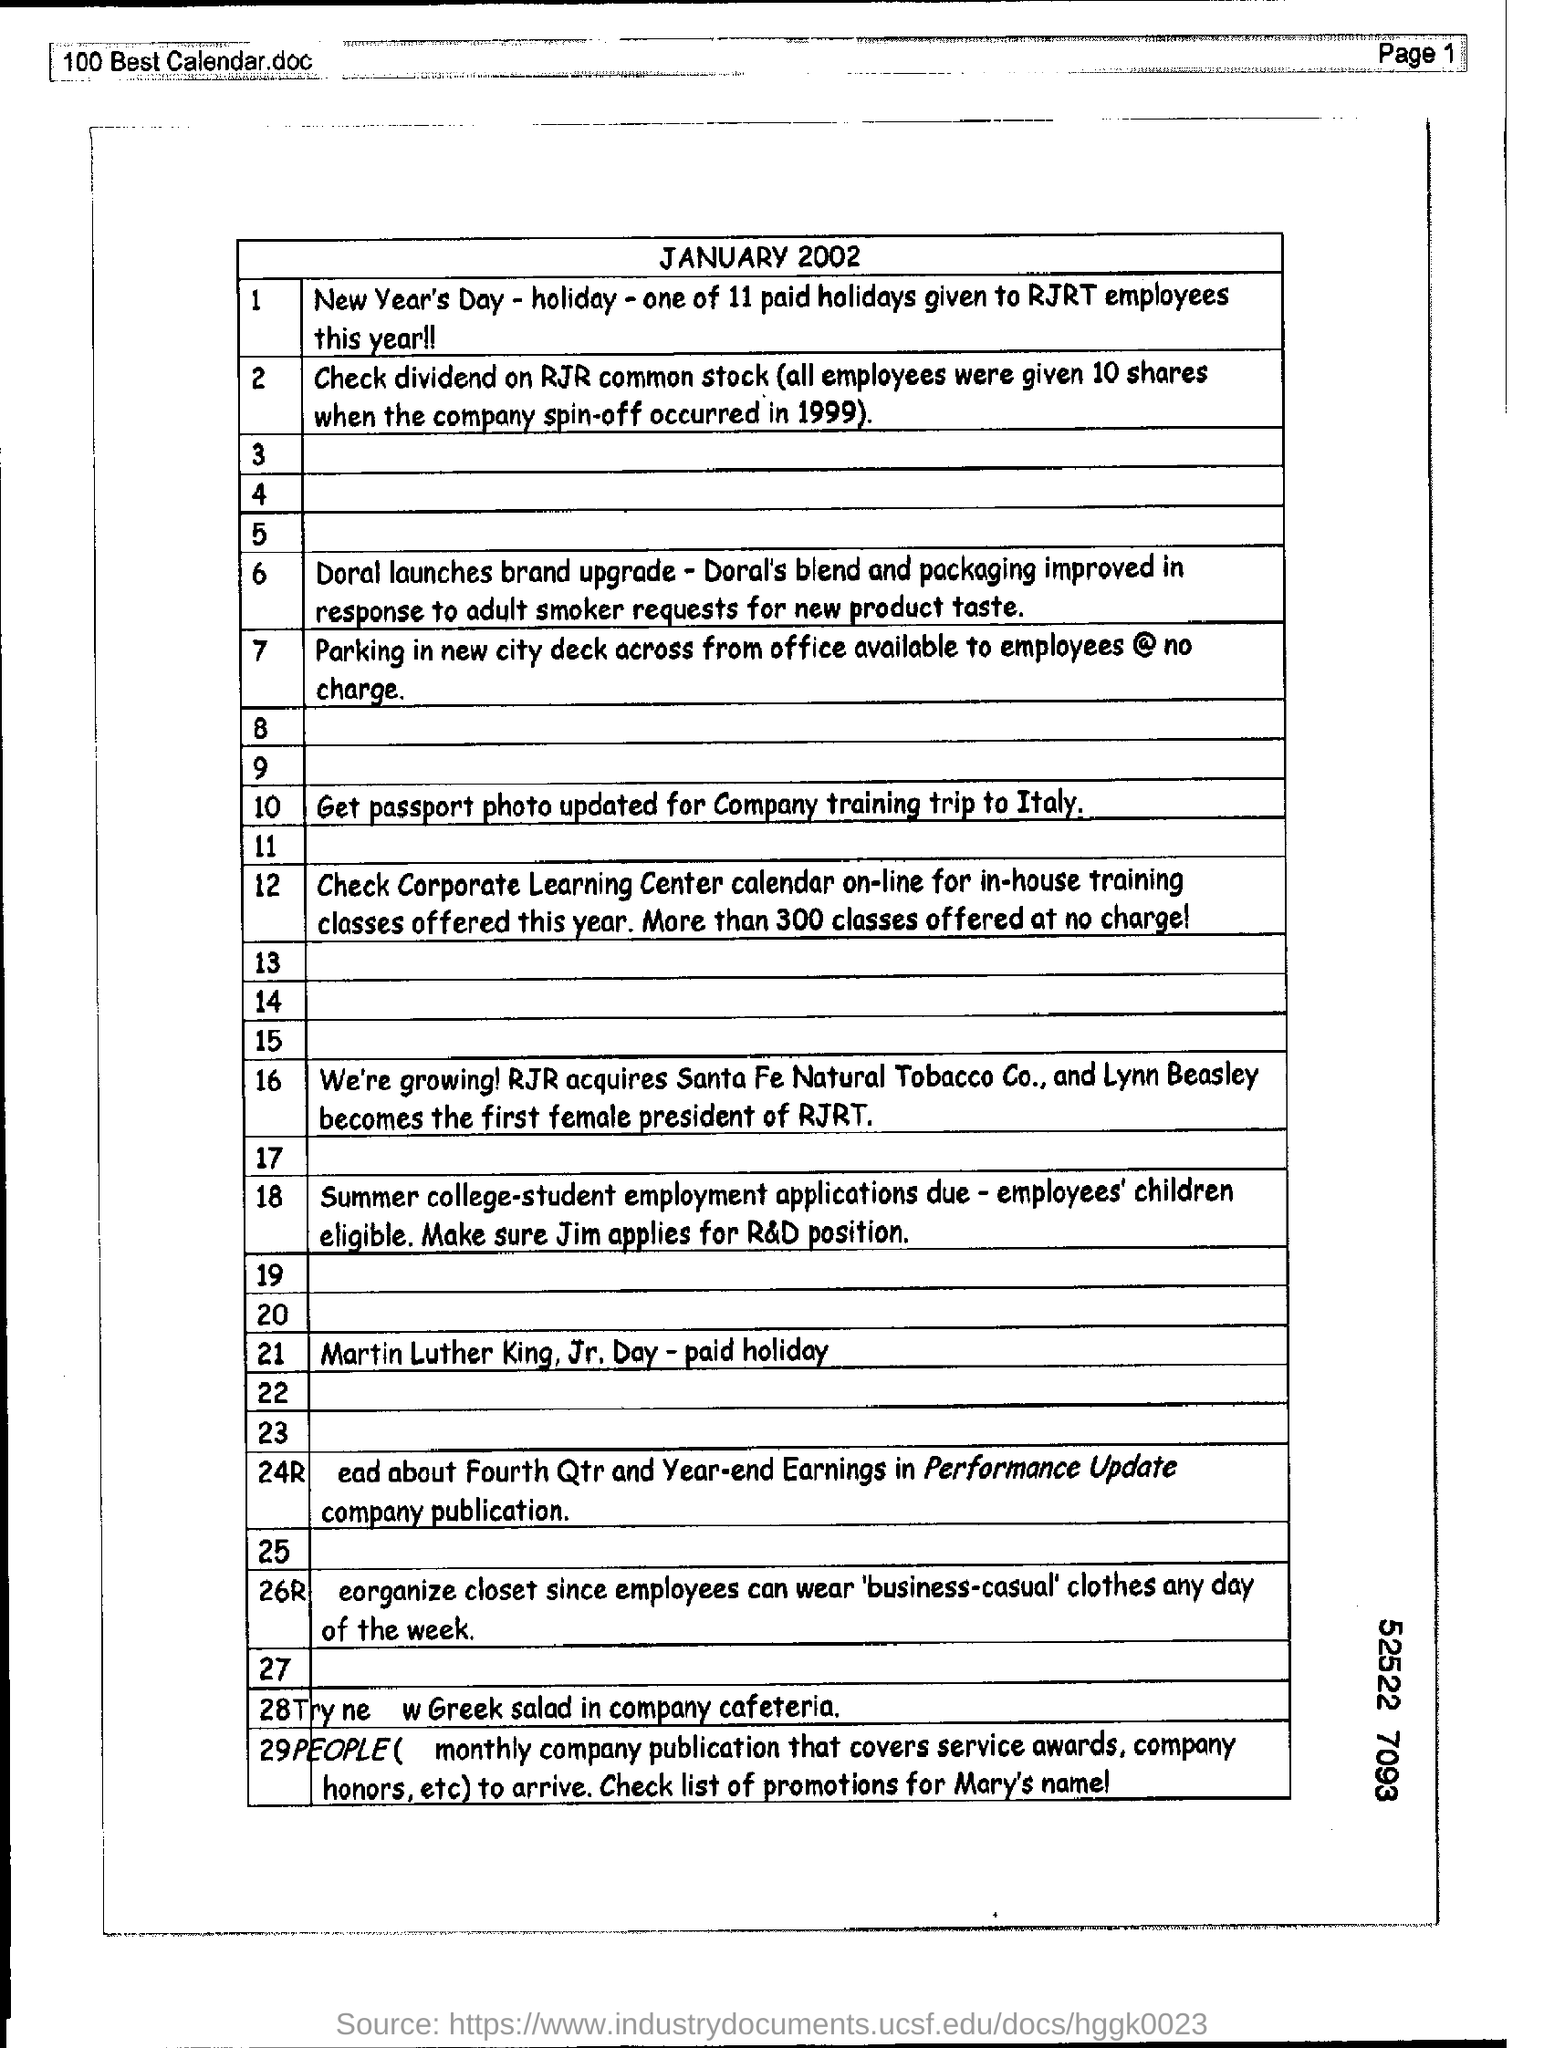Specify some key components in this picture. In 1999, the spin-off of the company occurred. Out of the total number of holidays given to RJRT employees this year, 11 have been paid or provided. All employees collectively donated 10 shares to the company. There are 300 classes available for free. The document provides a mention of the date "JANUARY 2002". 